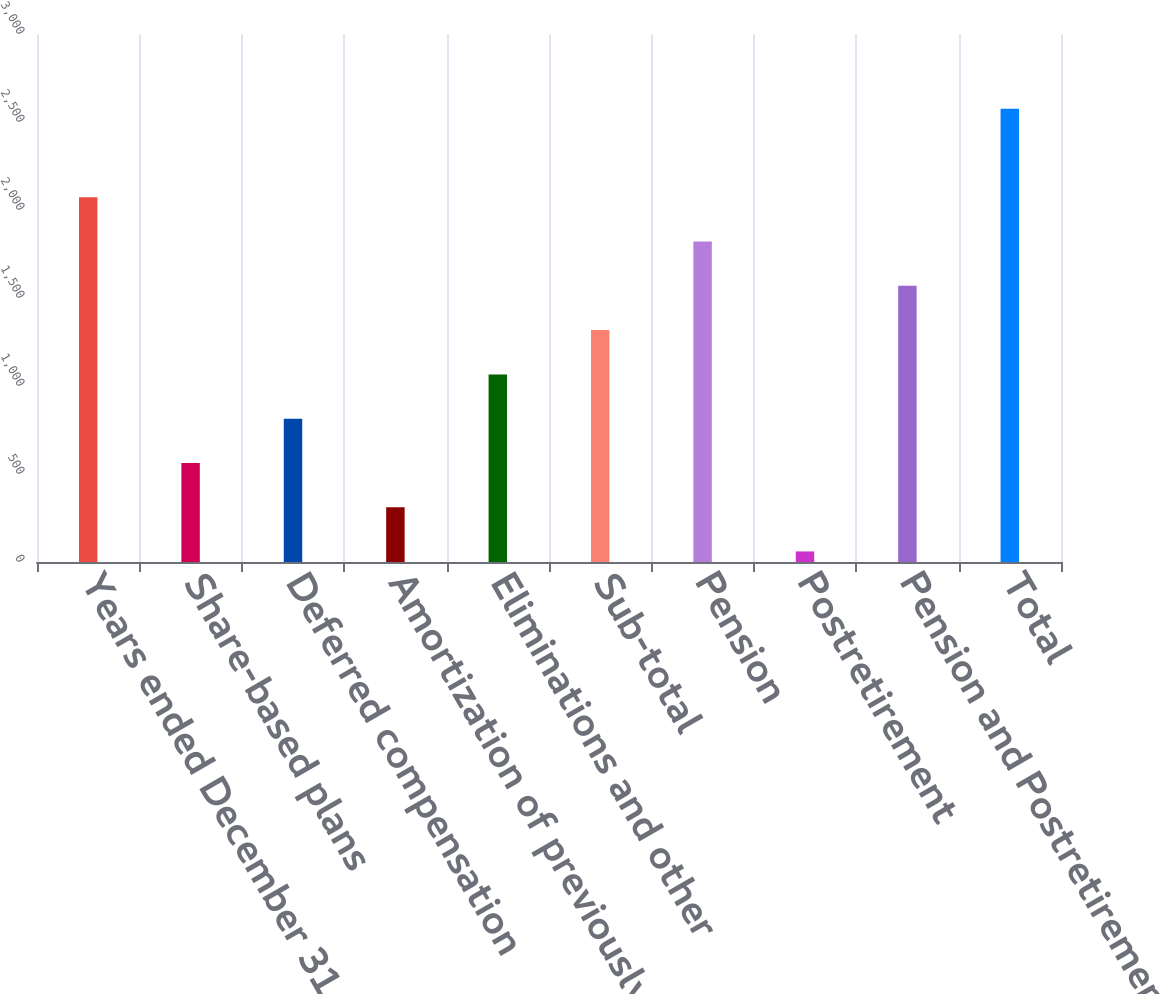Convert chart to OTSL. <chart><loc_0><loc_0><loc_500><loc_500><bar_chart><fcel>Years ended December 31<fcel>Share-based plans<fcel>Deferred compensation<fcel>Amortization of previously<fcel>Eliminations and other<fcel>Sub-total<fcel>Pension<fcel>Postretirement<fcel>Pension and Postretirement<fcel>Total<nl><fcel>2072<fcel>563<fcel>814.5<fcel>311.5<fcel>1066<fcel>1317.5<fcel>1820.5<fcel>60<fcel>1569<fcel>2575<nl></chart> 